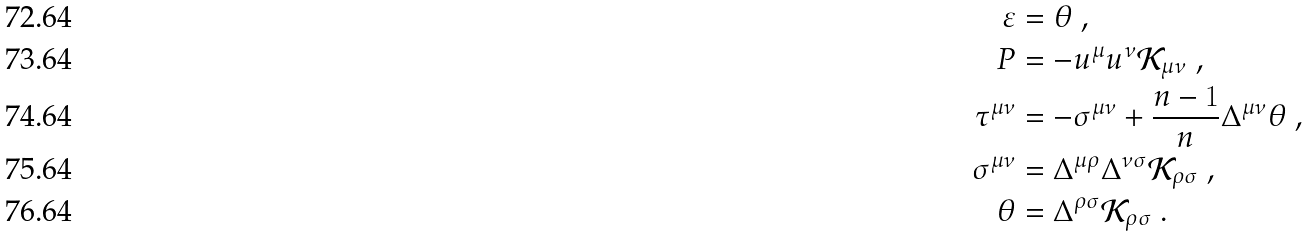<formula> <loc_0><loc_0><loc_500><loc_500>\varepsilon & = \theta \ , \\ P & = - u ^ { \mu } u ^ { \nu } \mathcal { K } _ { \mu \nu } \ , \\ \tau ^ { \mu \nu } & = - \sigma ^ { \mu \nu } + \frac { n - 1 } { n } \Delta ^ { \mu \nu } \theta \ , \\ \sigma ^ { \mu \nu } & = \Delta ^ { \mu \rho } \Delta ^ { \nu \sigma } \mathcal { K } _ { \rho \sigma } \ , \\ \theta & = \Delta ^ { \rho \sigma } \mathcal { K } _ { \rho \sigma } \ .</formula> 